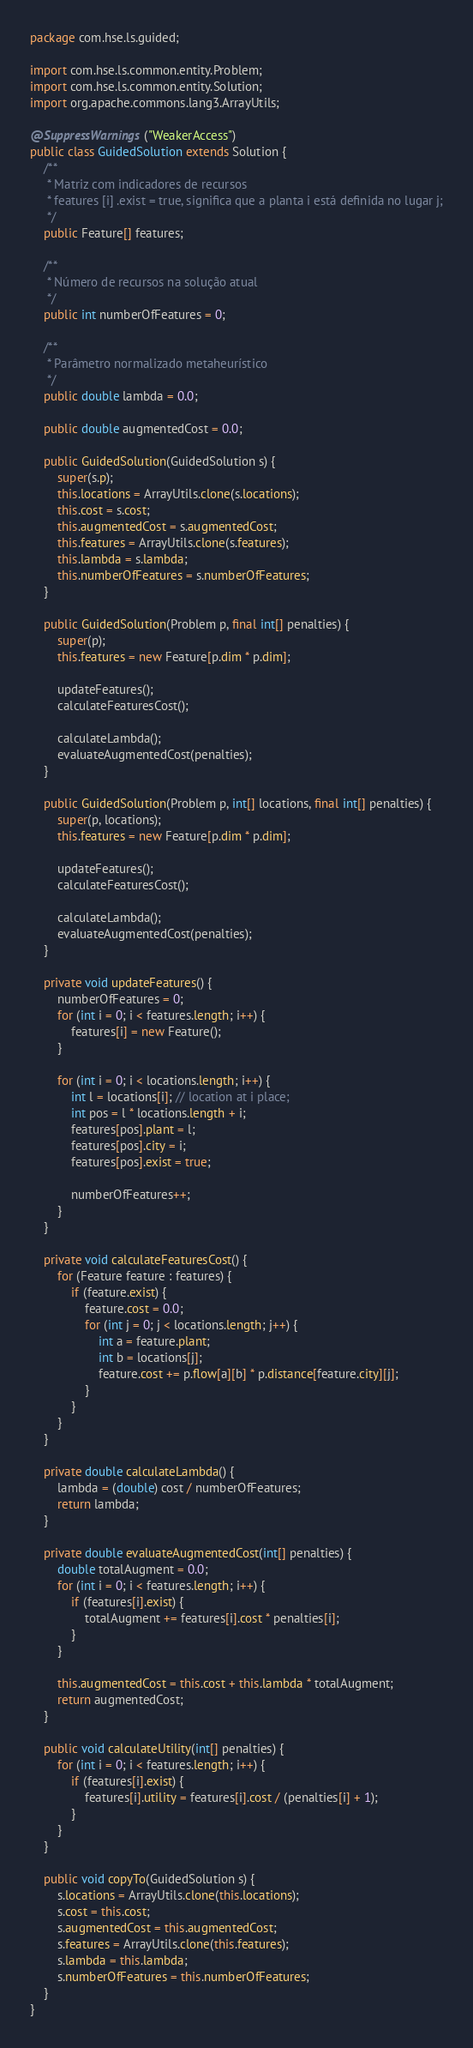Convert code to text. <code><loc_0><loc_0><loc_500><loc_500><_Java_>package com.hse.ls.guided;

import com.hse.ls.common.entity.Problem;
import com.hse.ls.common.entity.Solution;
import org.apache.commons.lang3.ArrayUtils;

@SuppressWarnings("WeakerAccess")
public class GuidedSolution extends Solution {
    /**
     * Matriz com indicadores de recursos
     * features [i] .exist = true, significa que a planta i está definida no lugar j;
     */
    public Feature[] features;

    /**
     * Número de recursos na solução atual
     */
    public int numberOfFeatures = 0;

    /**
     * Parâmetro normalizado metaheurístico
     */
    public double lambda = 0.0;

    public double augmentedCost = 0.0;

    public GuidedSolution(GuidedSolution s) {
        super(s.p);
        this.locations = ArrayUtils.clone(s.locations);
        this.cost = s.cost;
        this.augmentedCost = s.augmentedCost;
        this.features = ArrayUtils.clone(s.features);
        this.lambda = s.lambda;
        this.numberOfFeatures = s.numberOfFeatures;
    }

    public GuidedSolution(Problem p, final int[] penalties) {
        super(p);
        this.features = new Feature[p.dim * p.dim];

        updateFeatures();
        calculateFeaturesCost();

        calculateLambda();
        evaluateAugmentedCost(penalties);
    }

    public GuidedSolution(Problem p, int[] locations, final int[] penalties) {
        super(p, locations);
        this.features = new Feature[p.dim * p.dim];

        updateFeatures();
        calculateFeaturesCost();

        calculateLambda();
        evaluateAugmentedCost(penalties);
    }

    private void updateFeatures() {
        numberOfFeatures = 0;
        for (int i = 0; i < features.length; i++) {
            features[i] = new Feature();
        }

        for (int i = 0; i < locations.length; i++) {
            int l = locations[i]; // location at i place;
            int pos = l * locations.length + i;
            features[pos].plant = l;
            features[pos].city = i;
            features[pos].exist = true;

            numberOfFeatures++;
        }
    }

    private void calculateFeaturesCost() {
        for (Feature feature : features) {
            if (feature.exist) {
                feature.cost = 0.0;
                for (int j = 0; j < locations.length; j++) {
                    int a = feature.plant;
                    int b = locations[j];
                    feature.cost += p.flow[a][b] * p.distance[feature.city][j];
                }
            }
        }
    }

    private double calculateLambda() {
        lambda = (double) cost / numberOfFeatures;
        return lambda;
    }

    private double evaluateAugmentedCost(int[] penalties) {
        double totalAugment = 0.0;
        for (int i = 0; i < features.length; i++) {
            if (features[i].exist) {
                totalAugment += features[i].cost * penalties[i];
            }
        }

        this.augmentedCost = this.cost + this.lambda * totalAugment;
        return augmentedCost;
    }

    public void calculateUtility(int[] penalties) {
        for (int i = 0; i < features.length; i++) {
            if (features[i].exist) {
                features[i].utility = features[i].cost / (penalties[i] + 1);
            }
        }
    }

    public void copyTo(GuidedSolution s) {
        s.locations = ArrayUtils.clone(this.locations);
        s.cost = this.cost;
        s.augmentedCost = this.augmentedCost;
        s.features = ArrayUtils.clone(this.features);
        s.lambda = this.lambda;
        s.numberOfFeatures = this.numberOfFeatures;
    }
}
</code> 